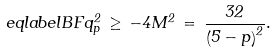<formula> <loc_0><loc_0><loc_500><loc_500>\ e q l a b e l { B F } q _ { p } ^ { 2 } \, \geq \, - 4 M ^ { 2 } \, = \, \frac { 3 2 } { \left ( 5 - p \right ) ^ { 2 } } .</formula> 